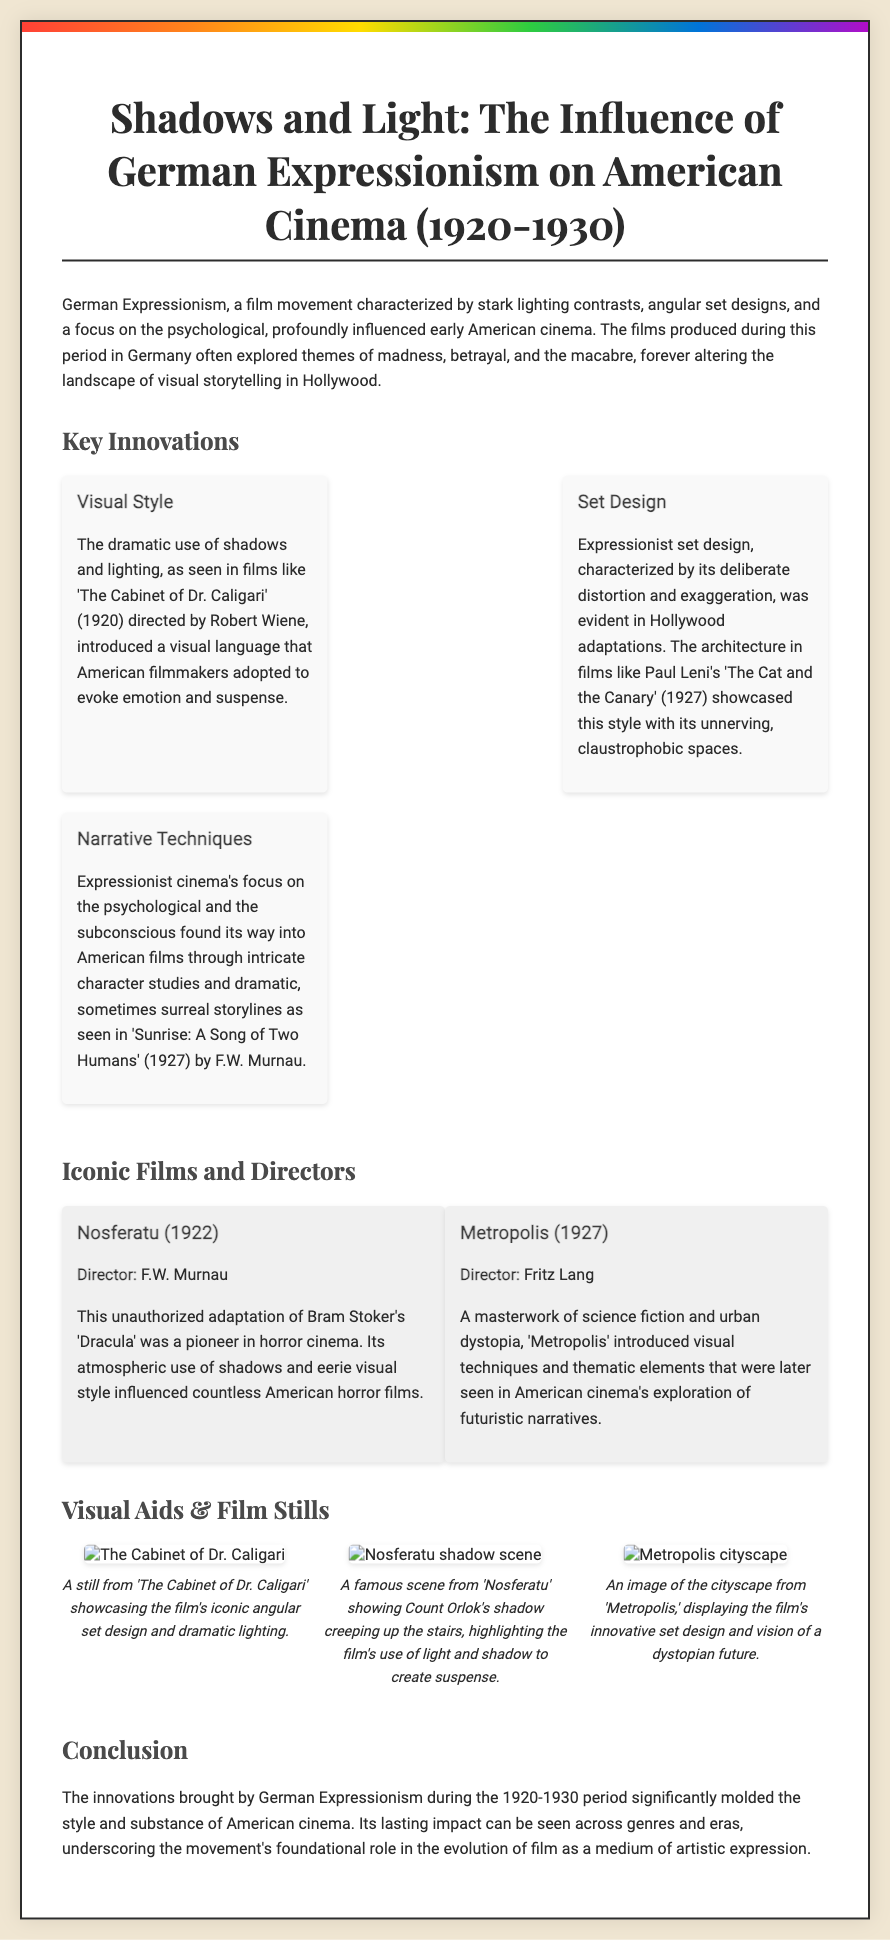what are the years covered in the retrospective? The document explicitly states that the retrospective covers the years 1920-1930.
Answer: 1920-1930 who directed 'Nosferatu'? The document mentions that 'Nosferatu' (1922) was directed by F.W. Murnau.
Answer: F.W. Murnau which film is associated with the concept of psychological and subconscious narratives? The narrative techniques linked to psychological themes are exemplified in 'Sunrise: A Song of Two Humans'.
Answer: Sunrise: A Song of Two Humans what visual technique is prominently featured in 'The Cabinet of Dr. Caligari'? The film is noted for its dramatic use of shadows and lighting.
Answer: Shadows and lighting how many key innovations are highlighted in the document? There are three key innovations mentioned in the retrospective.
Answer: Three what type of set design is discussed in relation to 'The Cat and the Canary'? The document describes the set design as distorted and exaggerated.
Answer: Distorted and exaggerated which film is noted for introducing a visual depiction of a dystopian future? 'Metropolis' (1927) is recognized for its urban dystopia imagery.
Answer: Metropolis what is the overarching theme of German Expressionism in the films listed? The themes explored include madness, betrayal, and the macabre.
Answer: Madness, betrayal, and the macabre how many visual aids are included in the document? The document provides three visual aids related to the films.
Answer: Three 